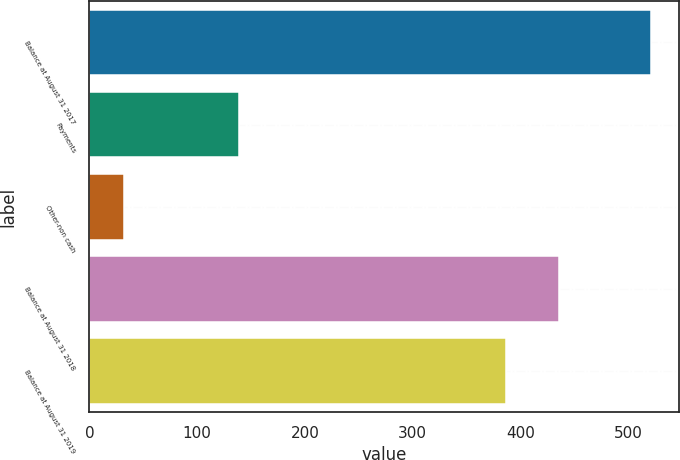Convert chart to OTSL. <chart><loc_0><loc_0><loc_500><loc_500><bar_chart><fcel>Balance at August 31 2017<fcel>Payments<fcel>Other-non cash<fcel>Balance at August 31 2018<fcel>Balance at August 31 2019<nl><fcel>521<fcel>139<fcel>32<fcel>435.9<fcel>387<nl></chart> 